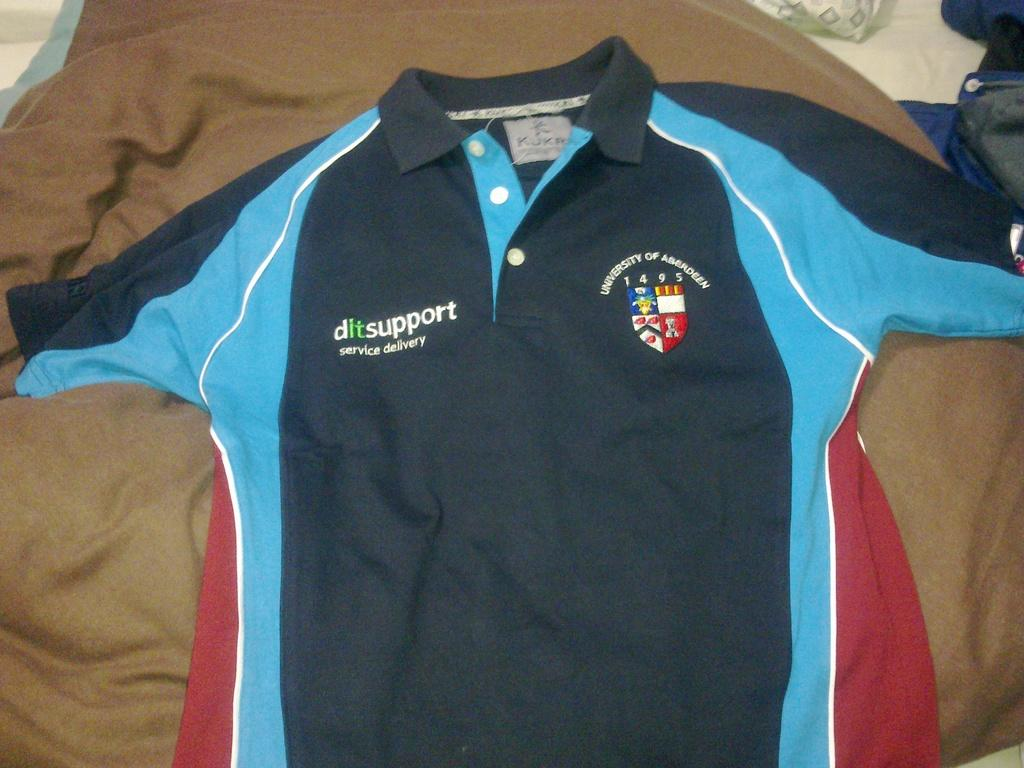Provide a one-sentence caption for the provided image. A black blue and red polo shirt from the University of Aberdeen. 